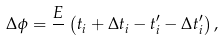<formula> <loc_0><loc_0><loc_500><loc_500>\Delta \phi = \frac { E } { } \left ( t _ { i } + \Delta t _ { i } - t ^ { \prime } _ { i } - \Delta t ^ { \prime } _ { i } \right ) ,</formula> 